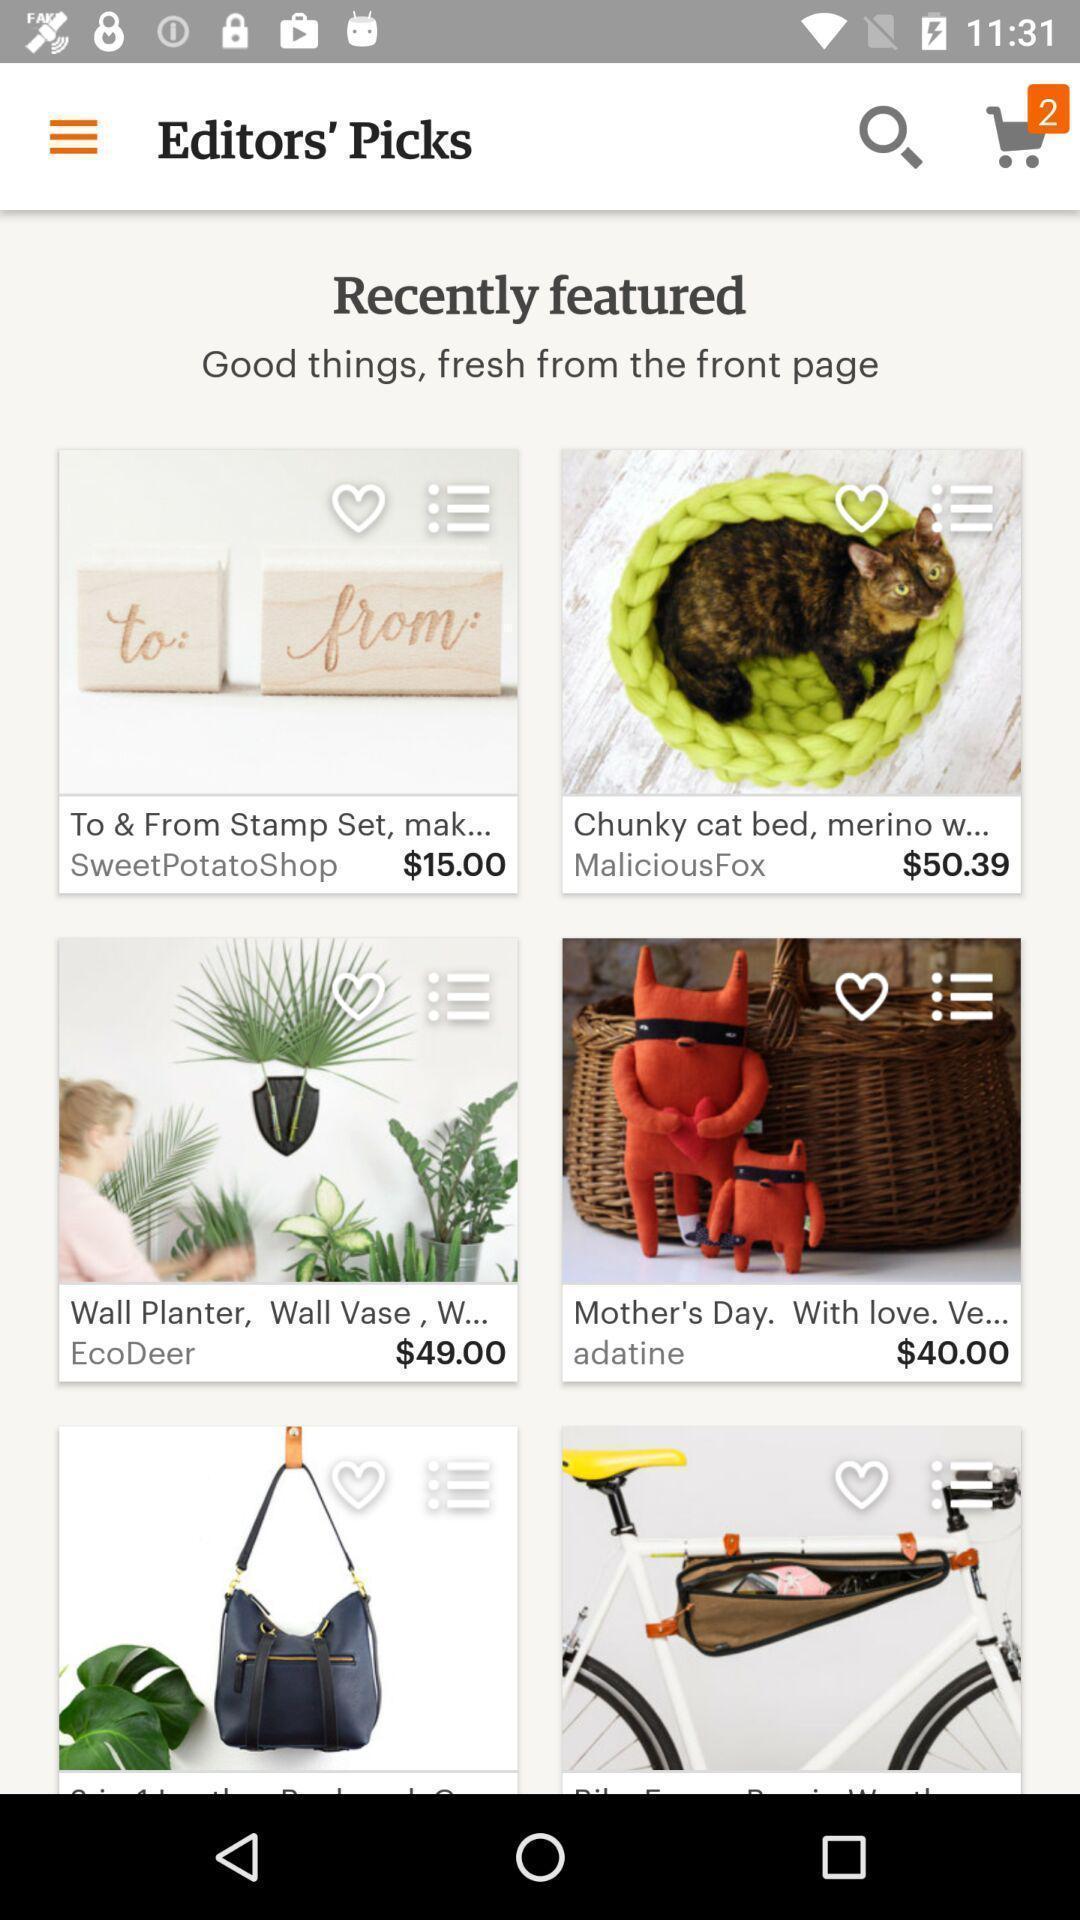Give me a summary of this screen capture. Page showing listings in a shopping based app. 